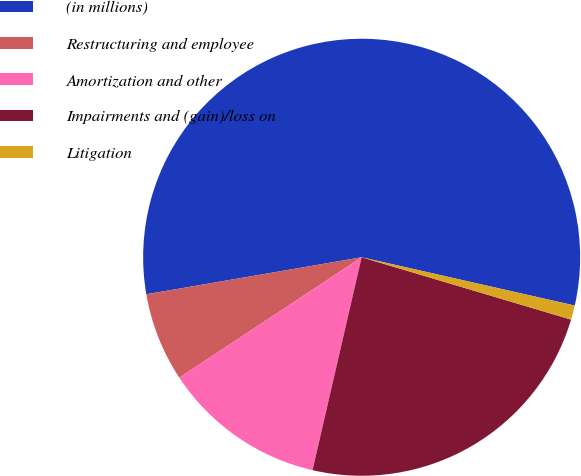Convert chart to OTSL. <chart><loc_0><loc_0><loc_500><loc_500><pie_chart><fcel>(in millions)<fcel>Restructuring and employee<fcel>Amortization and other<fcel>Impairments and (gain)/loss on<fcel>Litigation<nl><fcel>56.25%<fcel>6.58%<fcel>12.1%<fcel>24.0%<fcel>1.06%<nl></chart> 